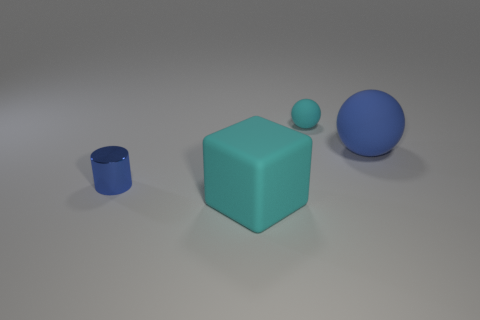Add 2 large cyan rubber blocks. How many objects exist? 6 Subtract all cylinders. How many objects are left? 3 Subtract all cyan blocks. Subtract all small blue cylinders. How many objects are left? 2 Add 2 large cyan matte objects. How many large cyan matte objects are left? 3 Add 3 large blue metal balls. How many large blue metal balls exist? 3 Subtract 0 gray spheres. How many objects are left? 4 